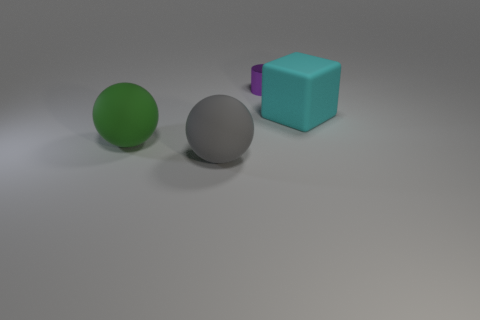Is there any other thing that is the same material as the purple thing?
Offer a very short reply. No. The purple metallic object has what size?
Your answer should be very brief. Small. Does the small thing have the same color as the big matte block?
Give a very brief answer. No. What is the size of the purple cylinder behind the big gray rubber object?
Your answer should be very brief. Small. What number of other things are there of the same shape as the tiny purple thing?
Your response must be concise. 0. Is the number of green spheres that are behind the large green object the same as the number of cyan things right of the metal cylinder?
Provide a succinct answer. No. Is the ball right of the green thing made of the same material as the purple cylinder that is behind the green object?
Give a very brief answer. No. How many other things are there of the same size as the cyan matte object?
Give a very brief answer. 2. How many objects are large blocks or balls behind the gray ball?
Keep it short and to the point. 2. Are there an equal number of large matte cubes that are behind the green thing and big cyan rubber cubes?
Give a very brief answer. Yes. 